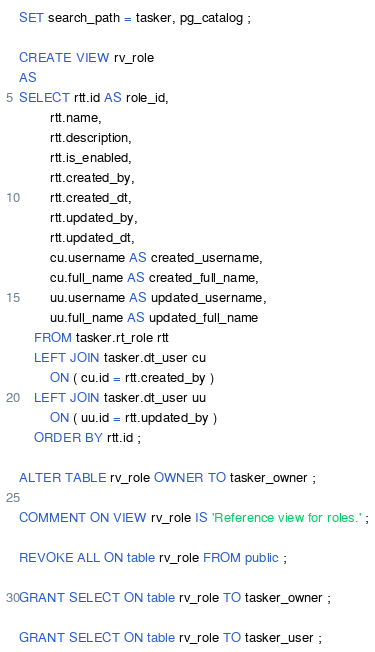<code> <loc_0><loc_0><loc_500><loc_500><_SQL_>SET search_path = tasker, pg_catalog ;

CREATE VIEW rv_role
AS
SELECT rtt.id AS role_id,
        rtt.name,
        rtt.description,
        rtt.is_enabled,
        rtt.created_by,
        rtt.created_dt,
        rtt.updated_by,
        rtt.updated_dt,
        cu.username AS created_username,
        cu.full_name AS created_full_name,
        uu.username AS updated_username,
        uu.full_name AS updated_full_name
    FROM tasker.rt_role rtt
    LEFT JOIN tasker.dt_user cu
        ON ( cu.id = rtt.created_by )
    LEFT JOIN tasker.dt_user uu
        ON ( uu.id = rtt.updated_by )
    ORDER BY rtt.id ;

ALTER TABLE rv_role OWNER TO tasker_owner ;

COMMENT ON VIEW rv_role IS 'Reference view for roles.' ;

REVOKE ALL ON table rv_role FROM public ;

GRANT SELECT ON table rv_role TO tasker_owner ;

GRANT SELECT ON table rv_role TO tasker_user ;
</code> 